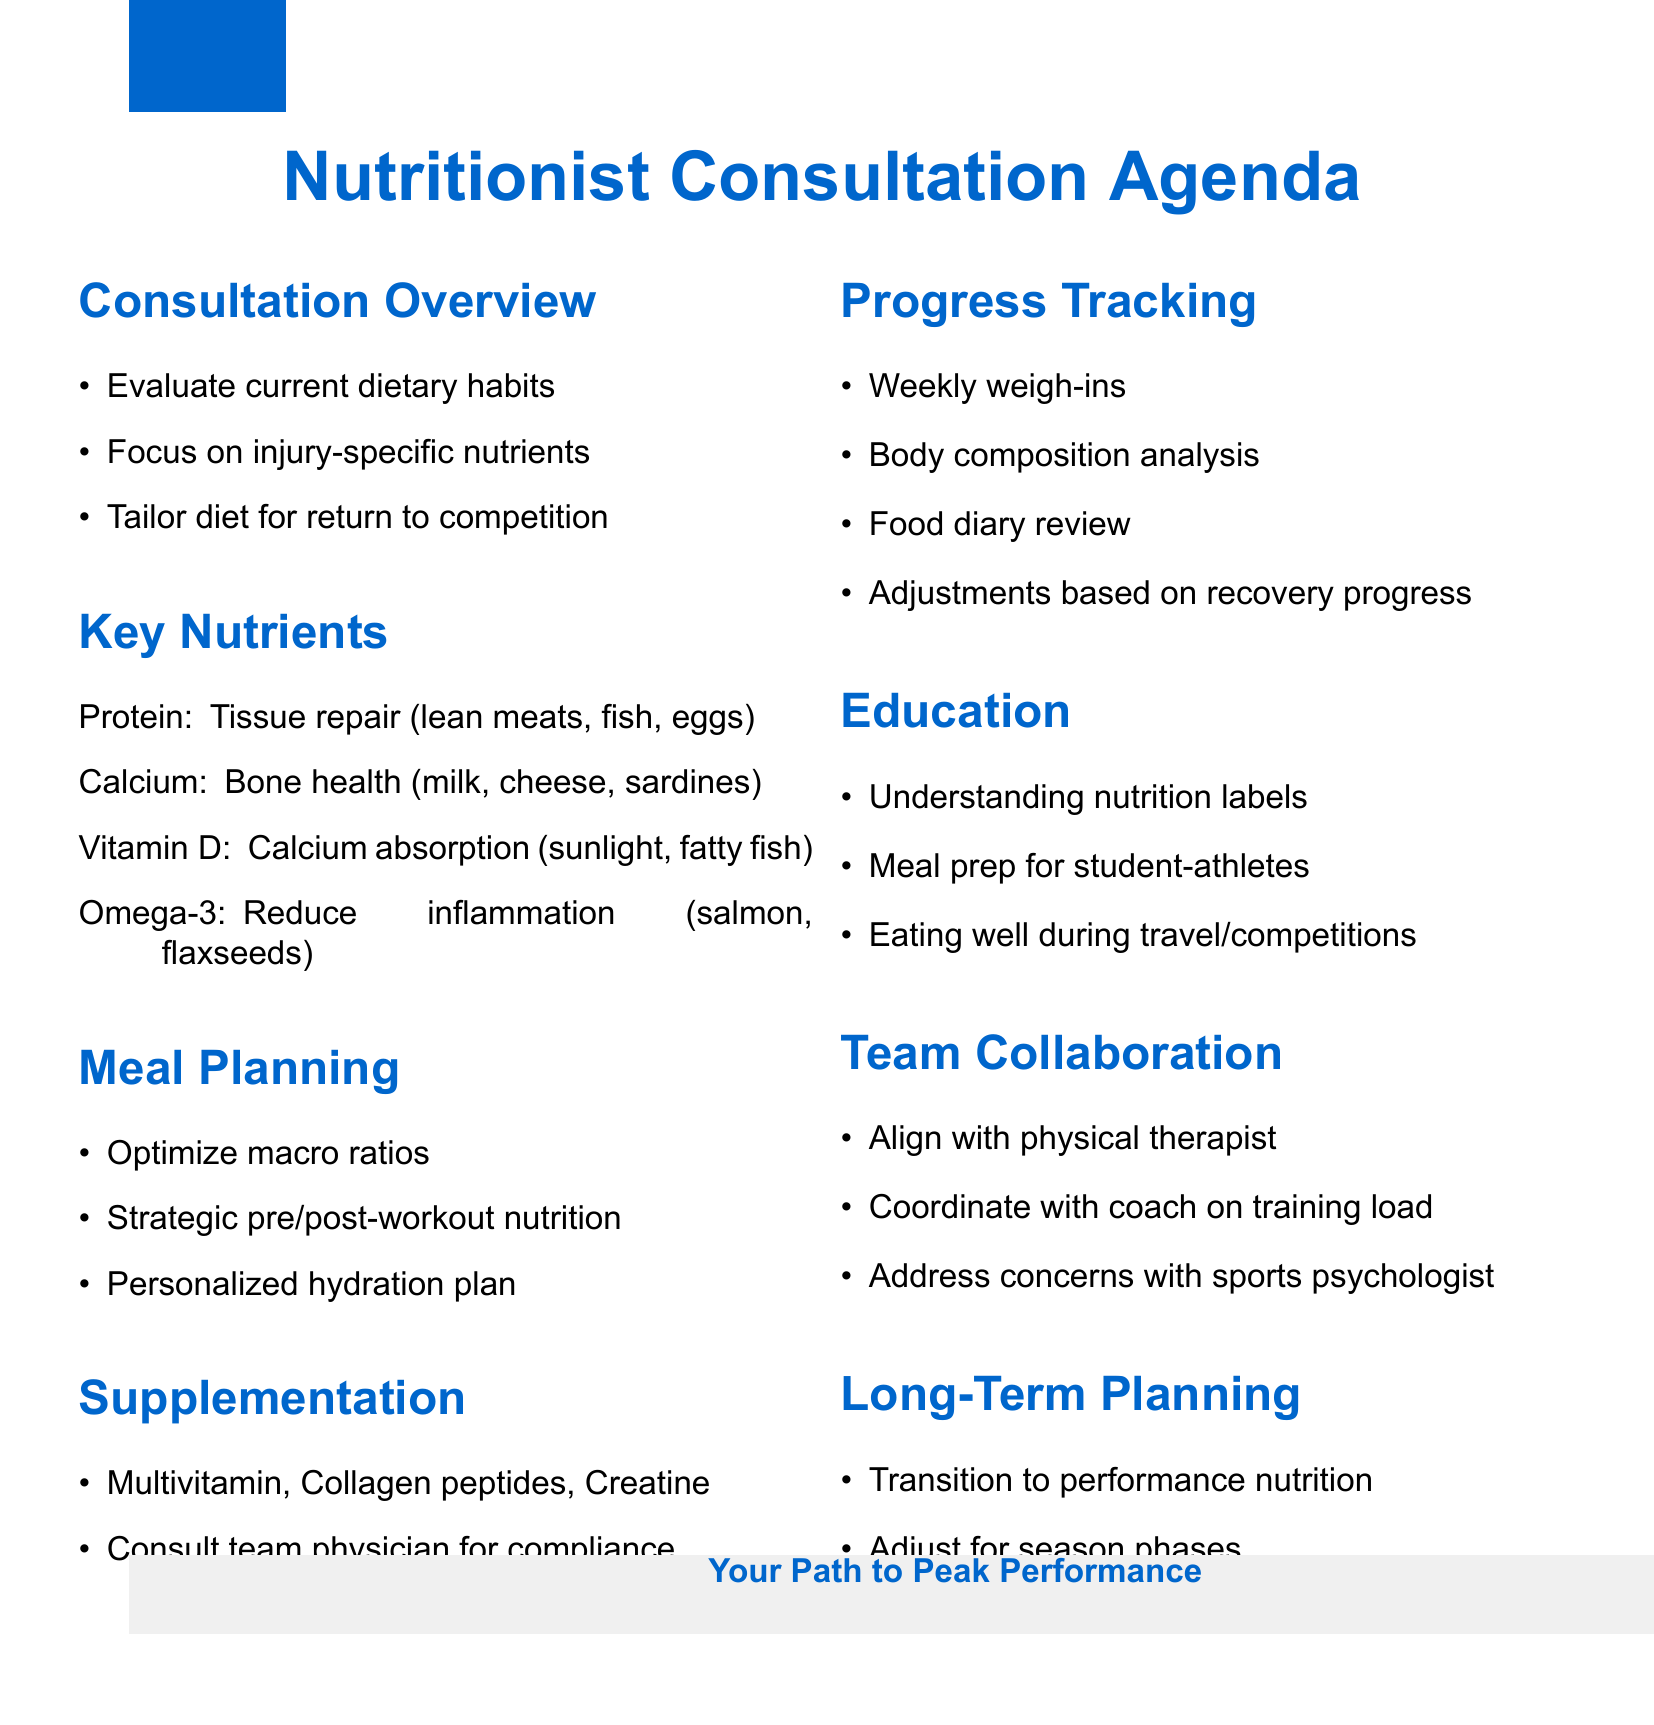What is the first step in the consultation overview? The first step is to evaluate current dietary habits and nutritional status.
Answer: Evaluate current dietary habits Which nutrient is essential for tissue repair? Protein is essential for tissue repair and muscle rebuilding according to the document.
Answer: Protein What are the sources of Omega-3 fatty acids? The document lists salmon, flaxseeds, walnuts, and fish oil supplements as sources.
Answer: Salmon, flaxseeds, walnuts, fish oil supplements What is a key component of the meal planning strategy? The document states that balancing macronutrients is key for recovery and performance.
Answer: Optimize carbohydrate, protein, and fat ratios What is the cautionary note regarding supplementation? The document advises to discuss all supplements with the team physician and check for compliance with anti-doping regulations.
Answer: Discuss all supplements with team physician How often should progress tracking methods be conducted? The document suggests conducting weekly weigh-ins as part of the progress tracking methods.
Answer: Weekly weigh-ins What is an example of an education component mentioned? Understanding nutrition labels is one of the education components highlighted in the document.
Answer: Understanding nutrition labels Who should the nutrition plan align with according to the team collaboration section? The nutrition plan should align with the physical therapist according to the team collaboration section.
Answer: Physical therapist What is the focus during the long-term planning phase? The focus is on transitioning to maintenance and performance nutrition.
Answer: Transition to performance nutrition 